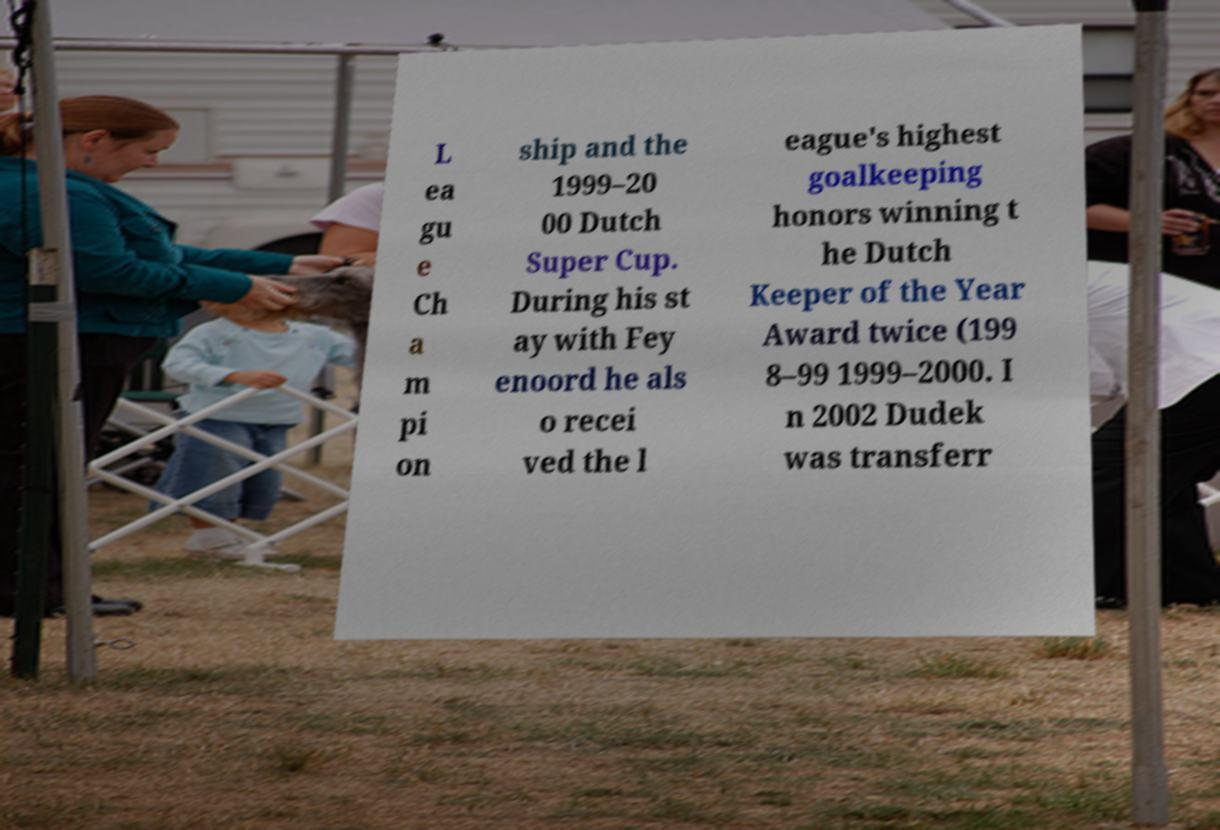I need the written content from this picture converted into text. Can you do that? L ea gu e Ch a m pi on ship and the 1999–20 00 Dutch Super Cup. During his st ay with Fey enoord he als o recei ved the l eague's highest goalkeeping honors winning t he Dutch Keeper of the Year Award twice (199 8–99 1999–2000. I n 2002 Dudek was transferr 